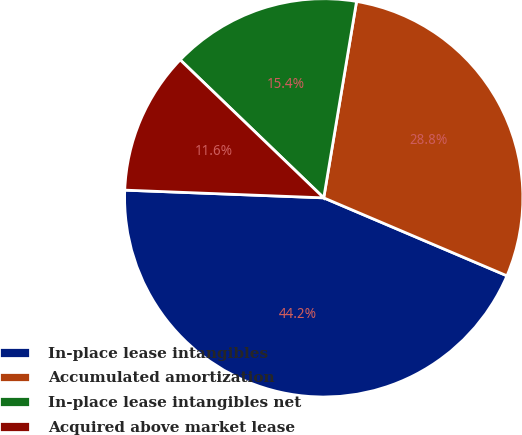Convert chart to OTSL. <chart><loc_0><loc_0><loc_500><loc_500><pie_chart><fcel>In-place lease intangibles<fcel>Accumulated amortization<fcel>In-place lease intangibles net<fcel>Acquired above market lease<nl><fcel>44.22%<fcel>28.77%<fcel>15.45%<fcel>11.57%<nl></chart> 